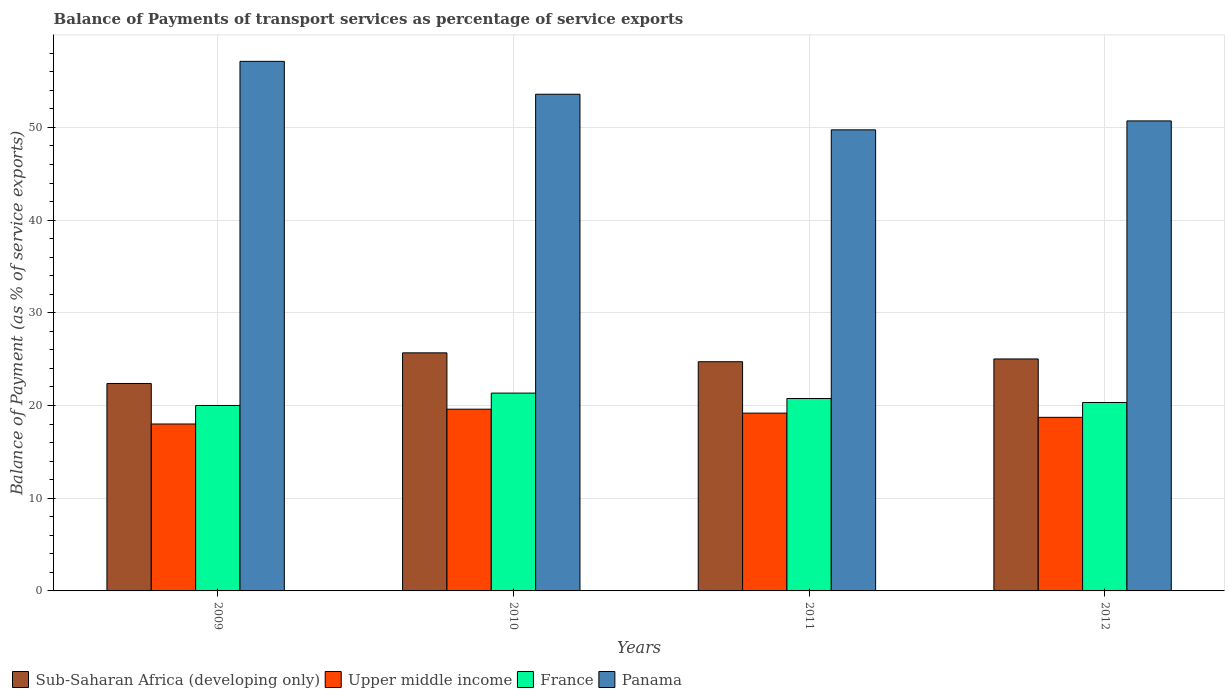How many different coloured bars are there?
Give a very brief answer. 4. How many groups of bars are there?
Offer a terse response. 4. What is the label of the 1st group of bars from the left?
Offer a terse response. 2009. In how many cases, is the number of bars for a given year not equal to the number of legend labels?
Offer a very short reply. 0. What is the balance of payments of transport services in Sub-Saharan Africa (developing only) in 2010?
Your response must be concise. 25.68. Across all years, what is the maximum balance of payments of transport services in Upper middle income?
Give a very brief answer. 19.6. Across all years, what is the minimum balance of payments of transport services in France?
Keep it short and to the point. 20. In which year was the balance of payments of transport services in France maximum?
Provide a short and direct response. 2010. What is the total balance of payments of transport services in Panama in the graph?
Your response must be concise. 211.14. What is the difference between the balance of payments of transport services in Upper middle income in 2010 and that in 2012?
Your response must be concise. 0.88. What is the difference between the balance of payments of transport services in Panama in 2010 and the balance of payments of transport services in France in 2012?
Provide a short and direct response. 33.25. What is the average balance of payments of transport services in Upper middle income per year?
Keep it short and to the point. 18.88. In the year 2009, what is the difference between the balance of payments of transport services in Sub-Saharan Africa (developing only) and balance of payments of transport services in France?
Your answer should be very brief. 2.37. In how many years, is the balance of payments of transport services in Upper middle income greater than 30 %?
Your response must be concise. 0. What is the ratio of the balance of payments of transport services in France in 2010 to that in 2011?
Provide a succinct answer. 1.03. Is the balance of payments of transport services in Sub-Saharan Africa (developing only) in 2010 less than that in 2012?
Provide a short and direct response. No. What is the difference between the highest and the second highest balance of payments of transport services in Panama?
Offer a terse response. 3.55. What is the difference between the highest and the lowest balance of payments of transport services in France?
Ensure brevity in your answer.  1.34. In how many years, is the balance of payments of transport services in Sub-Saharan Africa (developing only) greater than the average balance of payments of transport services in Sub-Saharan Africa (developing only) taken over all years?
Keep it short and to the point. 3. Is the sum of the balance of payments of transport services in Upper middle income in 2009 and 2012 greater than the maximum balance of payments of transport services in France across all years?
Give a very brief answer. Yes. What does the 4th bar from the left in 2010 represents?
Your answer should be compact. Panama. What does the 1st bar from the right in 2010 represents?
Make the answer very short. Panama. How many years are there in the graph?
Your response must be concise. 4. Does the graph contain any zero values?
Make the answer very short. No. How many legend labels are there?
Your answer should be very brief. 4. What is the title of the graph?
Provide a succinct answer. Balance of Payments of transport services as percentage of service exports. Does "Armenia" appear as one of the legend labels in the graph?
Keep it short and to the point. No. What is the label or title of the X-axis?
Provide a short and direct response. Years. What is the label or title of the Y-axis?
Provide a succinct answer. Balance of Payment (as % of service exports). What is the Balance of Payment (as % of service exports) of Sub-Saharan Africa (developing only) in 2009?
Provide a succinct answer. 22.38. What is the Balance of Payment (as % of service exports) in Upper middle income in 2009?
Make the answer very short. 18.01. What is the Balance of Payment (as % of service exports) in France in 2009?
Your response must be concise. 20. What is the Balance of Payment (as % of service exports) of Panama in 2009?
Make the answer very short. 57.12. What is the Balance of Payment (as % of service exports) of Sub-Saharan Africa (developing only) in 2010?
Offer a terse response. 25.68. What is the Balance of Payment (as % of service exports) of Upper middle income in 2010?
Offer a terse response. 19.6. What is the Balance of Payment (as % of service exports) of France in 2010?
Keep it short and to the point. 21.34. What is the Balance of Payment (as % of service exports) in Panama in 2010?
Provide a short and direct response. 53.58. What is the Balance of Payment (as % of service exports) of Sub-Saharan Africa (developing only) in 2011?
Keep it short and to the point. 24.72. What is the Balance of Payment (as % of service exports) of Upper middle income in 2011?
Ensure brevity in your answer.  19.18. What is the Balance of Payment (as % of service exports) of France in 2011?
Make the answer very short. 20.75. What is the Balance of Payment (as % of service exports) in Panama in 2011?
Your answer should be compact. 49.74. What is the Balance of Payment (as % of service exports) in Sub-Saharan Africa (developing only) in 2012?
Keep it short and to the point. 25.02. What is the Balance of Payment (as % of service exports) of Upper middle income in 2012?
Provide a short and direct response. 18.72. What is the Balance of Payment (as % of service exports) of France in 2012?
Keep it short and to the point. 20.33. What is the Balance of Payment (as % of service exports) of Panama in 2012?
Keep it short and to the point. 50.7. Across all years, what is the maximum Balance of Payment (as % of service exports) in Sub-Saharan Africa (developing only)?
Make the answer very short. 25.68. Across all years, what is the maximum Balance of Payment (as % of service exports) in Upper middle income?
Keep it short and to the point. 19.6. Across all years, what is the maximum Balance of Payment (as % of service exports) of France?
Your response must be concise. 21.34. Across all years, what is the maximum Balance of Payment (as % of service exports) of Panama?
Offer a terse response. 57.12. Across all years, what is the minimum Balance of Payment (as % of service exports) in Sub-Saharan Africa (developing only)?
Offer a terse response. 22.38. Across all years, what is the minimum Balance of Payment (as % of service exports) in Upper middle income?
Keep it short and to the point. 18.01. Across all years, what is the minimum Balance of Payment (as % of service exports) of France?
Ensure brevity in your answer.  20. Across all years, what is the minimum Balance of Payment (as % of service exports) in Panama?
Make the answer very short. 49.74. What is the total Balance of Payment (as % of service exports) of Sub-Saharan Africa (developing only) in the graph?
Ensure brevity in your answer.  97.8. What is the total Balance of Payment (as % of service exports) in Upper middle income in the graph?
Your answer should be very brief. 75.51. What is the total Balance of Payment (as % of service exports) of France in the graph?
Make the answer very short. 82.42. What is the total Balance of Payment (as % of service exports) in Panama in the graph?
Provide a short and direct response. 211.14. What is the difference between the Balance of Payment (as % of service exports) in Sub-Saharan Africa (developing only) in 2009 and that in 2010?
Give a very brief answer. -3.3. What is the difference between the Balance of Payment (as % of service exports) in Upper middle income in 2009 and that in 2010?
Your response must be concise. -1.6. What is the difference between the Balance of Payment (as % of service exports) in France in 2009 and that in 2010?
Provide a short and direct response. -1.34. What is the difference between the Balance of Payment (as % of service exports) of Panama in 2009 and that in 2010?
Your answer should be compact. 3.55. What is the difference between the Balance of Payment (as % of service exports) in Sub-Saharan Africa (developing only) in 2009 and that in 2011?
Keep it short and to the point. -2.35. What is the difference between the Balance of Payment (as % of service exports) of Upper middle income in 2009 and that in 2011?
Give a very brief answer. -1.17. What is the difference between the Balance of Payment (as % of service exports) of France in 2009 and that in 2011?
Keep it short and to the point. -0.75. What is the difference between the Balance of Payment (as % of service exports) in Panama in 2009 and that in 2011?
Your answer should be compact. 7.39. What is the difference between the Balance of Payment (as % of service exports) in Sub-Saharan Africa (developing only) in 2009 and that in 2012?
Your answer should be very brief. -2.65. What is the difference between the Balance of Payment (as % of service exports) in Upper middle income in 2009 and that in 2012?
Ensure brevity in your answer.  -0.72. What is the difference between the Balance of Payment (as % of service exports) in France in 2009 and that in 2012?
Make the answer very short. -0.32. What is the difference between the Balance of Payment (as % of service exports) of Panama in 2009 and that in 2012?
Keep it short and to the point. 6.42. What is the difference between the Balance of Payment (as % of service exports) in Sub-Saharan Africa (developing only) in 2010 and that in 2011?
Provide a succinct answer. 0.96. What is the difference between the Balance of Payment (as % of service exports) in Upper middle income in 2010 and that in 2011?
Offer a very short reply. 0.43. What is the difference between the Balance of Payment (as % of service exports) in France in 2010 and that in 2011?
Your answer should be very brief. 0.58. What is the difference between the Balance of Payment (as % of service exports) of Panama in 2010 and that in 2011?
Your response must be concise. 3.84. What is the difference between the Balance of Payment (as % of service exports) of Sub-Saharan Africa (developing only) in 2010 and that in 2012?
Ensure brevity in your answer.  0.66. What is the difference between the Balance of Payment (as % of service exports) of Upper middle income in 2010 and that in 2012?
Keep it short and to the point. 0.88. What is the difference between the Balance of Payment (as % of service exports) in France in 2010 and that in 2012?
Keep it short and to the point. 1.01. What is the difference between the Balance of Payment (as % of service exports) of Panama in 2010 and that in 2012?
Give a very brief answer. 2.88. What is the difference between the Balance of Payment (as % of service exports) of Sub-Saharan Africa (developing only) in 2011 and that in 2012?
Keep it short and to the point. -0.3. What is the difference between the Balance of Payment (as % of service exports) in Upper middle income in 2011 and that in 2012?
Your answer should be compact. 0.45. What is the difference between the Balance of Payment (as % of service exports) of France in 2011 and that in 2012?
Keep it short and to the point. 0.43. What is the difference between the Balance of Payment (as % of service exports) of Panama in 2011 and that in 2012?
Offer a terse response. -0.96. What is the difference between the Balance of Payment (as % of service exports) of Sub-Saharan Africa (developing only) in 2009 and the Balance of Payment (as % of service exports) of Upper middle income in 2010?
Keep it short and to the point. 2.77. What is the difference between the Balance of Payment (as % of service exports) in Sub-Saharan Africa (developing only) in 2009 and the Balance of Payment (as % of service exports) in France in 2010?
Provide a short and direct response. 1.04. What is the difference between the Balance of Payment (as % of service exports) of Sub-Saharan Africa (developing only) in 2009 and the Balance of Payment (as % of service exports) of Panama in 2010?
Keep it short and to the point. -31.2. What is the difference between the Balance of Payment (as % of service exports) of Upper middle income in 2009 and the Balance of Payment (as % of service exports) of France in 2010?
Make the answer very short. -3.33. What is the difference between the Balance of Payment (as % of service exports) in Upper middle income in 2009 and the Balance of Payment (as % of service exports) in Panama in 2010?
Provide a short and direct response. -35.57. What is the difference between the Balance of Payment (as % of service exports) of France in 2009 and the Balance of Payment (as % of service exports) of Panama in 2010?
Offer a very short reply. -33.57. What is the difference between the Balance of Payment (as % of service exports) in Sub-Saharan Africa (developing only) in 2009 and the Balance of Payment (as % of service exports) in Upper middle income in 2011?
Offer a terse response. 3.2. What is the difference between the Balance of Payment (as % of service exports) of Sub-Saharan Africa (developing only) in 2009 and the Balance of Payment (as % of service exports) of France in 2011?
Give a very brief answer. 1.62. What is the difference between the Balance of Payment (as % of service exports) of Sub-Saharan Africa (developing only) in 2009 and the Balance of Payment (as % of service exports) of Panama in 2011?
Provide a short and direct response. -27.36. What is the difference between the Balance of Payment (as % of service exports) in Upper middle income in 2009 and the Balance of Payment (as % of service exports) in France in 2011?
Offer a very short reply. -2.75. What is the difference between the Balance of Payment (as % of service exports) of Upper middle income in 2009 and the Balance of Payment (as % of service exports) of Panama in 2011?
Your answer should be very brief. -31.73. What is the difference between the Balance of Payment (as % of service exports) of France in 2009 and the Balance of Payment (as % of service exports) of Panama in 2011?
Offer a terse response. -29.73. What is the difference between the Balance of Payment (as % of service exports) of Sub-Saharan Africa (developing only) in 2009 and the Balance of Payment (as % of service exports) of Upper middle income in 2012?
Your answer should be compact. 3.65. What is the difference between the Balance of Payment (as % of service exports) in Sub-Saharan Africa (developing only) in 2009 and the Balance of Payment (as % of service exports) in France in 2012?
Provide a succinct answer. 2.05. What is the difference between the Balance of Payment (as % of service exports) of Sub-Saharan Africa (developing only) in 2009 and the Balance of Payment (as % of service exports) of Panama in 2012?
Provide a short and direct response. -28.32. What is the difference between the Balance of Payment (as % of service exports) of Upper middle income in 2009 and the Balance of Payment (as % of service exports) of France in 2012?
Provide a short and direct response. -2.32. What is the difference between the Balance of Payment (as % of service exports) of Upper middle income in 2009 and the Balance of Payment (as % of service exports) of Panama in 2012?
Provide a succinct answer. -32.69. What is the difference between the Balance of Payment (as % of service exports) of France in 2009 and the Balance of Payment (as % of service exports) of Panama in 2012?
Provide a short and direct response. -30.7. What is the difference between the Balance of Payment (as % of service exports) in Sub-Saharan Africa (developing only) in 2010 and the Balance of Payment (as % of service exports) in Upper middle income in 2011?
Your response must be concise. 6.5. What is the difference between the Balance of Payment (as % of service exports) of Sub-Saharan Africa (developing only) in 2010 and the Balance of Payment (as % of service exports) of France in 2011?
Give a very brief answer. 4.93. What is the difference between the Balance of Payment (as % of service exports) in Sub-Saharan Africa (developing only) in 2010 and the Balance of Payment (as % of service exports) in Panama in 2011?
Your response must be concise. -24.06. What is the difference between the Balance of Payment (as % of service exports) of Upper middle income in 2010 and the Balance of Payment (as % of service exports) of France in 2011?
Keep it short and to the point. -1.15. What is the difference between the Balance of Payment (as % of service exports) of Upper middle income in 2010 and the Balance of Payment (as % of service exports) of Panama in 2011?
Ensure brevity in your answer.  -30.13. What is the difference between the Balance of Payment (as % of service exports) in France in 2010 and the Balance of Payment (as % of service exports) in Panama in 2011?
Provide a short and direct response. -28.4. What is the difference between the Balance of Payment (as % of service exports) in Sub-Saharan Africa (developing only) in 2010 and the Balance of Payment (as % of service exports) in Upper middle income in 2012?
Give a very brief answer. 6.96. What is the difference between the Balance of Payment (as % of service exports) of Sub-Saharan Africa (developing only) in 2010 and the Balance of Payment (as % of service exports) of France in 2012?
Offer a very short reply. 5.35. What is the difference between the Balance of Payment (as % of service exports) of Sub-Saharan Africa (developing only) in 2010 and the Balance of Payment (as % of service exports) of Panama in 2012?
Offer a terse response. -25.02. What is the difference between the Balance of Payment (as % of service exports) in Upper middle income in 2010 and the Balance of Payment (as % of service exports) in France in 2012?
Your answer should be very brief. -0.72. What is the difference between the Balance of Payment (as % of service exports) of Upper middle income in 2010 and the Balance of Payment (as % of service exports) of Panama in 2012?
Keep it short and to the point. -31.1. What is the difference between the Balance of Payment (as % of service exports) in France in 2010 and the Balance of Payment (as % of service exports) in Panama in 2012?
Keep it short and to the point. -29.36. What is the difference between the Balance of Payment (as % of service exports) in Sub-Saharan Africa (developing only) in 2011 and the Balance of Payment (as % of service exports) in Upper middle income in 2012?
Give a very brief answer. 6. What is the difference between the Balance of Payment (as % of service exports) of Sub-Saharan Africa (developing only) in 2011 and the Balance of Payment (as % of service exports) of France in 2012?
Keep it short and to the point. 4.4. What is the difference between the Balance of Payment (as % of service exports) in Sub-Saharan Africa (developing only) in 2011 and the Balance of Payment (as % of service exports) in Panama in 2012?
Your answer should be compact. -25.98. What is the difference between the Balance of Payment (as % of service exports) in Upper middle income in 2011 and the Balance of Payment (as % of service exports) in France in 2012?
Your answer should be compact. -1.15. What is the difference between the Balance of Payment (as % of service exports) of Upper middle income in 2011 and the Balance of Payment (as % of service exports) of Panama in 2012?
Give a very brief answer. -31.52. What is the difference between the Balance of Payment (as % of service exports) of France in 2011 and the Balance of Payment (as % of service exports) of Panama in 2012?
Provide a succinct answer. -29.95. What is the average Balance of Payment (as % of service exports) in Sub-Saharan Africa (developing only) per year?
Offer a terse response. 24.45. What is the average Balance of Payment (as % of service exports) in Upper middle income per year?
Keep it short and to the point. 18.88. What is the average Balance of Payment (as % of service exports) of France per year?
Provide a short and direct response. 20.61. What is the average Balance of Payment (as % of service exports) in Panama per year?
Ensure brevity in your answer.  52.78. In the year 2009, what is the difference between the Balance of Payment (as % of service exports) of Sub-Saharan Africa (developing only) and Balance of Payment (as % of service exports) of Upper middle income?
Your answer should be compact. 4.37. In the year 2009, what is the difference between the Balance of Payment (as % of service exports) in Sub-Saharan Africa (developing only) and Balance of Payment (as % of service exports) in France?
Provide a succinct answer. 2.37. In the year 2009, what is the difference between the Balance of Payment (as % of service exports) of Sub-Saharan Africa (developing only) and Balance of Payment (as % of service exports) of Panama?
Make the answer very short. -34.75. In the year 2009, what is the difference between the Balance of Payment (as % of service exports) in Upper middle income and Balance of Payment (as % of service exports) in France?
Your answer should be compact. -2. In the year 2009, what is the difference between the Balance of Payment (as % of service exports) in Upper middle income and Balance of Payment (as % of service exports) in Panama?
Give a very brief answer. -39.12. In the year 2009, what is the difference between the Balance of Payment (as % of service exports) of France and Balance of Payment (as % of service exports) of Panama?
Give a very brief answer. -37.12. In the year 2010, what is the difference between the Balance of Payment (as % of service exports) of Sub-Saharan Africa (developing only) and Balance of Payment (as % of service exports) of Upper middle income?
Give a very brief answer. 6.08. In the year 2010, what is the difference between the Balance of Payment (as % of service exports) of Sub-Saharan Africa (developing only) and Balance of Payment (as % of service exports) of France?
Your response must be concise. 4.34. In the year 2010, what is the difference between the Balance of Payment (as % of service exports) of Sub-Saharan Africa (developing only) and Balance of Payment (as % of service exports) of Panama?
Provide a short and direct response. -27.9. In the year 2010, what is the difference between the Balance of Payment (as % of service exports) in Upper middle income and Balance of Payment (as % of service exports) in France?
Offer a very short reply. -1.73. In the year 2010, what is the difference between the Balance of Payment (as % of service exports) in Upper middle income and Balance of Payment (as % of service exports) in Panama?
Offer a very short reply. -33.97. In the year 2010, what is the difference between the Balance of Payment (as % of service exports) of France and Balance of Payment (as % of service exports) of Panama?
Ensure brevity in your answer.  -32.24. In the year 2011, what is the difference between the Balance of Payment (as % of service exports) in Sub-Saharan Africa (developing only) and Balance of Payment (as % of service exports) in Upper middle income?
Offer a terse response. 5.54. In the year 2011, what is the difference between the Balance of Payment (as % of service exports) of Sub-Saharan Africa (developing only) and Balance of Payment (as % of service exports) of France?
Provide a short and direct response. 3.97. In the year 2011, what is the difference between the Balance of Payment (as % of service exports) in Sub-Saharan Africa (developing only) and Balance of Payment (as % of service exports) in Panama?
Provide a short and direct response. -25.01. In the year 2011, what is the difference between the Balance of Payment (as % of service exports) of Upper middle income and Balance of Payment (as % of service exports) of France?
Your answer should be very brief. -1.58. In the year 2011, what is the difference between the Balance of Payment (as % of service exports) of Upper middle income and Balance of Payment (as % of service exports) of Panama?
Give a very brief answer. -30.56. In the year 2011, what is the difference between the Balance of Payment (as % of service exports) in France and Balance of Payment (as % of service exports) in Panama?
Make the answer very short. -28.98. In the year 2012, what is the difference between the Balance of Payment (as % of service exports) of Sub-Saharan Africa (developing only) and Balance of Payment (as % of service exports) of Upper middle income?
Provide a short and direct response. 6.3. In the year 2012, what is the difference between the Balance of Payment (as % of service exports) in Sub-Saharan Africa (developing only) and Balance of Payment (as % of service exports) in France?
Keep it short and to the point. 4.7. In the year 2012, what is the difference between the Balance of Payment (as % of service exports) in Sub-Saharan Africa (developing only) and Balance of Payment (as % of service exports) in Panama?
Your answer should be very brief. -25.68. In the year 2012, what is the difference between the Balance of Payment (as % of service exports) in Upper middle income and Balance of Payment (as % of service exports) in France?
Provide a short and direct response. -1.6. In the year 2012, what is the difference between the Balance of Payment (as % of service exports) in Upper middle income and Balance of Payment (as % of service exports) in Panama?
Your response must be concise. -31.98. In the year 2012, what is the difference between the Balance of Payment (as % of service exports) of France and Balance of Payment (as % of service exports) of Panama?
Ensure brevity in your answer.  -30.37. What is the ratio of the Balance of Payment (as % of service exports) of Sub-Saharan Africa (developing only) in 2009 to that in 2010?
Your response must be concise. 0.87. What is the ratio of the Balance of Payment (as % of service exports) in Upper middle income in 2009 to that in 2010?
Provide a short and direct response. 0.92. What is the ratio of the Balance of Payment (as % of service exports) in France in 2009 to that in 2010?
Your answer should be very brief. 0.94. What is the ratio of the Balance of Payment (as % of service exports) of Panama in 2009 to that in 2010?
Ensure brevity in your answer.  1.07. What is the ratio of the Balance of Payment (as % of service exports) in Sub-Saharan Africa (developing only) in 2009 to that in 2011?
Make the answer very short. 0.91. What is the ratio of the Balance of Payment (as % of service exports) in Upper middle income in 2009 to that in 2011?
Provide a short and direct response. 0.94. What is the ratio of the Balance of Payment (as % of service exports) of France in 2009 to that in 2011?
Make the answer very short. 0.96. What is the ratio of the Balance of Payment (as % of service exports) in Panama in 2009 to that in 2011?
Offer a very short reply. 1.15. What is the ratio of the Balance of Payment (as % of service exports) of Sub-Saharan Africa (developing only) in 2009 to that in 2012?
Offer a very short reply. 0.89. What is the ratio of the Balance of Payment (as % of service exports) in Upper middle income in 2009 to that in 2012?
Give a very brief answer. 0.96. What is the ratio of the Balance of Payment (as % of service exports) in France in 2009 to that in 2012?
Keep it short and to the point. 0.98. What is the ratio of the Balance of Payment (as % of service exports) in Panama in 2009 to that in 2012?
Make the answer very short. 1.13. What is the ratio of the Balance of Payment (as % of service exports) of Sub-Saharan Africa (developing only) in 2010 to that in 2011?
Your response must be concise. 1.04. What is the ratio of the Balance of Payment (as % of service exports) of Upper middle income in 2010 to that in 2011?
Give a very brief answer. 1.02. What is the ratio of the Balance of Payment (as % of service exports) in France in 2010 to that in 2011?
Make the answer very short. 1.03. What is the ratio of the Balance of Payment (as % of service exports) in Panama in 2010 to that in 2011?
Keep it short and to the point. 1.08. What is the ratio of the Balance of Payment (as % of service exports) of Sub-Saharan Africa (developing only) in 2010 to that in 2012?
Keep it short and to the point. 1.03. What is the ratio of the Balance of Payment (as % of service exports) in Upper middle income in 2010 to that in 2012?
Your response must be concise. 1.05. What is the ratio of the Balance of Payment (as % of service exports) in France in 2010 to that in 2012?
Offer a very short reply. 1.05. What is the ratio of the Balance of Payment (as % of service exports) of Panama in 2010 to that in 2012?
Provide a succinct answer. 1.06. What is the ratio of the Balance of Payment (as % of service exports) in Sub-Saharan Africa (developing only) in 2011 to that in 2012?
Make the answer very short. 0.99. What is the ratio of the Balance of Payment (as % of service exports) in Upper middle income in 2011 to that in 2012?
Ensure brevity in your answer.  1.02. What is the ratio of the Balance of Payment (as % of service exports) of France in 2011 to that in 2012?
Your answer should be very brief. 1.02. What is the ratio of the Balance of Payment (as % of service exports) in Panama in 2011 to that in 2012?
Ensure brevity in your answer.  0.98. What is the difference between the highest and the second highest Balance of Payment (as % of service exports) of Sub-Saharan Africa (developing only)?
Your response must be concise. 0.66. What is the difference between the highest and the second highest Balance of Payment (as % of service exports) of Upper middle income?
Provide a short and direct response. 0.43. What is the difference between the highest and the second highest Balance of Payment (as % of service exports) in France?
Ensure brevity in your answer.  0.58. What is the difference between the highest and the second highest Balance of Payment (as % of service exports) of Panama?
Keep it short and to the point. 3.55. What is the difference between the highest and the lowest Balance of Payment (as % of service exports) in Sub-Saharan Africa (developing only)?
Your response must be concise. 3.3. What is the difference between the highest and the lowest Balance of Payment (as % of service exports) of Upper middle income?
Make the answer very short. 1.6. What is the difference between the highest and the lowest Balance of Payment (as % of service exports) in France?
Offer a terse response. 1.34. What is the difference between the highest and the lowest Balance of Payment (as % of service exports) in Panama?
Ensure brevity in your answer.  7.39. 